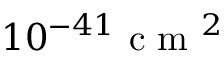Convert formula to latex. <formula><loc_0><loc_0><loc_500><loc_500>1 0 ^ { - 4 1 } { c m } ^ { 2 }</formula> 